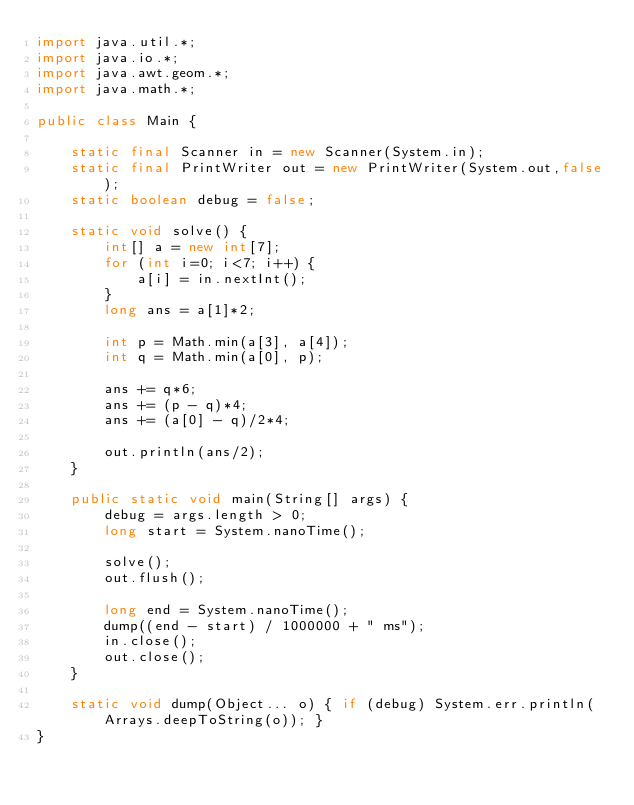Convert code to text. <code><loc_0><loc_0><loc_500><loc_500><_Java_>import java.util.*;
import java.io.*;
import java.awt.geom.*;
import java.math.*;

public class Main {

	static final Scanner in = new Scanner(System.in);
	static final PrintWriter out = new PrintWriter(System.out,false);
	static boolean debug = false;

	static void solve() {
		int[] a = new int[7];
		for (int i=0; i<7; i++) {
			a[i] = in.nextInt();
		}
		long ans = a[1]*2;

		int p = Math.min(a[3], a[4]);
		int q = Math.min(a[0], p);

		ans += q*6;
		ans += (p - q)*4;
		ans += (a[0] - q)/2*4;

		out.println(ans/2);
	}

	public static void main(String[] args) {
		debug = args.length > 0;
		long start = System.nanoTime();

		solve();
		out.flush();

		long end = System.nanoTime();
		dump((end - start) / 1000000 + " ms");
		in.close();
		out.close();
	}

	static void dump(Object... o) { if (debug) System.err.println(Arrays.deepToString(o)); }
}</code> 